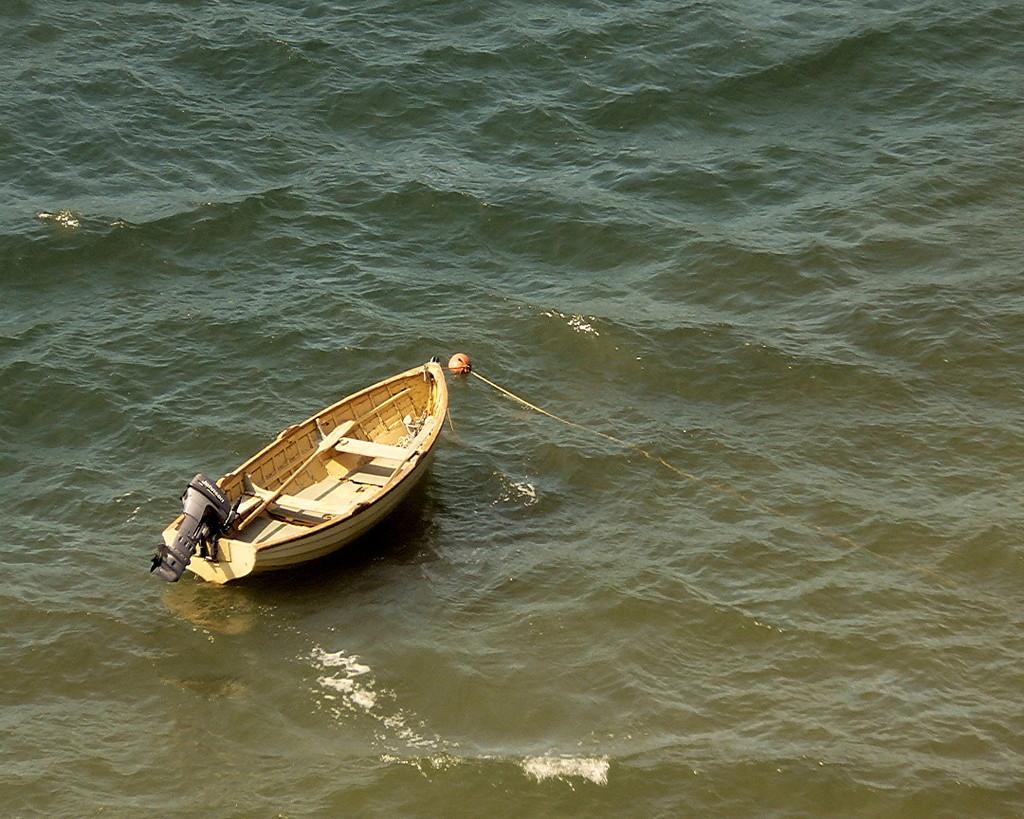Could you give a brief overview of what you see in this image? In this picture I can see boat on the water. 